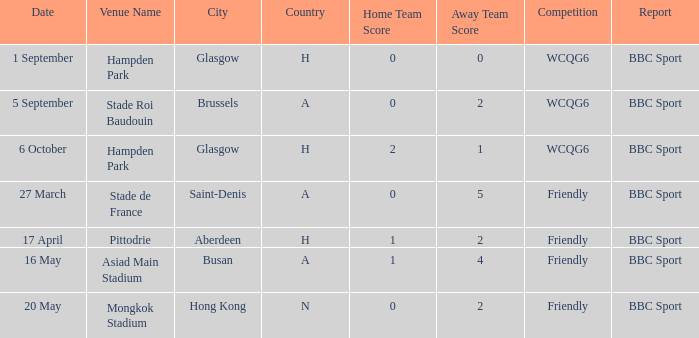Write the full table. {'header': ['Date', 'Venue Name', 'City', 'Country', 'Home Team Score', 'Away Team Score', 'Competition', 'Report'], 'rows': [['1 September', 'Hampden Park', 'Glasgow', 'H', '0', '0', 'WCQG6', 'BBC Sport'], ['5 September', 'Stade Roi Baudouin', 'Brussels', 'A', '0', '2', 'WCQG6', 'BBC Sport'], ['6 October', 'Hampden Park', 'Glasgow', 'H', '2', '1', 'WCQG6', 'BBC Sport'], ['27 March', 'Stade de France', 'Saint-Denis', 'A', '0', '5', 'Friendly', 'BBC Sport'], ['17 April', 'Pittodrie', 'Aberdeen', 'H', '1', '2', 'Friendly', 'BBC Sport'], ['16 May', 'Asiad Main Stadium', 'Busan', 'A', '1', '4', 'Friendly', 'BBC Sport'], ['20 May', 'Mongkok Stadium', 'Hong Kong', 'N', '0', '2', 'Friendly', 'BBC Sport']]} Can you tell me the score of the game that took place on the 1st of september? 0–0. 